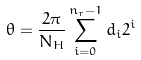<formula> <loc_0><loc_0><loc_500><loc_500>\theta = \frac { 2 \pi } { N _ { H } } \sum _ { i = 0 } ^ { n _ { r } - 1 } d _ { i } 2 ^ { i }</formula> 